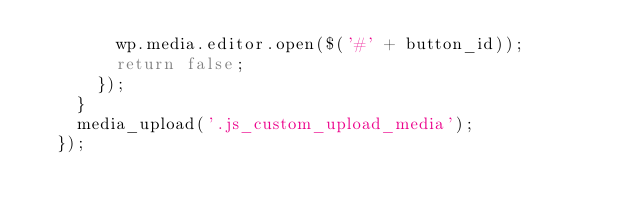Convert code to text. <code><loc_0><loc_0><loc_500><loc_500><_JavaScript_>        wp.media.editor.open($('#' + button_id));
        return false;
      });
    }
    media_upload('.js_custom_upload_media');
  });</code> 